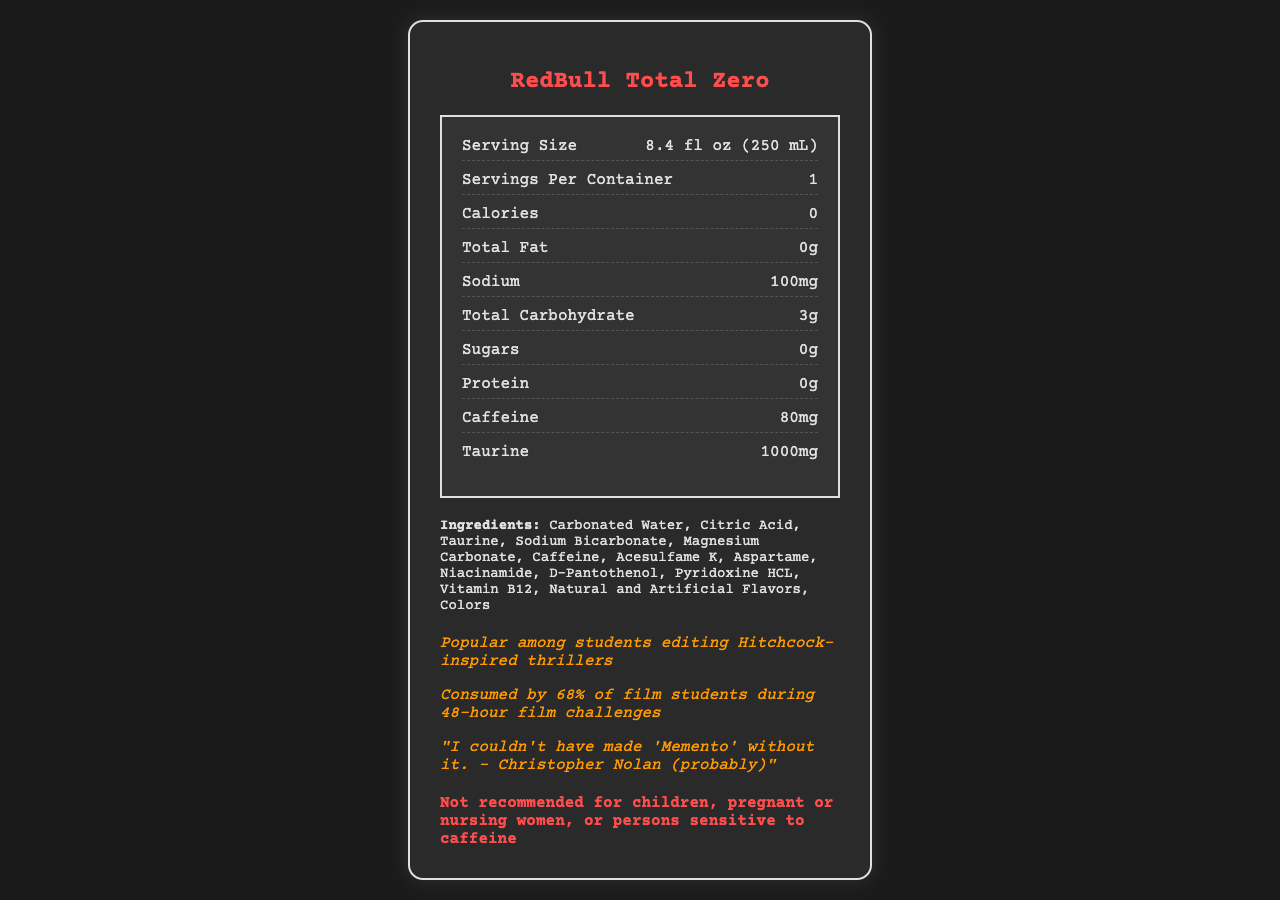what is the serving size? The serving size is listed near the top of the Nutrition Facts section of the document.
Answer: 8.4 fl oz (250 mL) how many servings are in a container? The document states "Servings Per Container" as 1.
Answer: 1 how much caffeine is in one serving? The amount of caffeine is listed under the nutrition item section.
Answer: 80mg list three key vitamins found in this energy drink. These vitamins are listed in the nutrition items section near the bottom.
Answer: vitamin b6, vitamin b12, niacin what is the total carbohydrate content per serving? The total carbohydrate content is listed under "Total Carbohydrate" in the nutrition section.
Answer: 3g which of these is NOT an ingredient in this energy drink? A. Taurine B. Magnesium Carbonate C. Glucose D. Acesulfame K The ingredients list includes Taurine, Magnesium Carbonate, and Acesulfame K, but not Glucose.
Answer: C. Glucose what is the warning regarding who should not consume this drink? A. Children B. Pregnant Women C. Persons sensitive to caffeine D. All of the above The warning section specifies that the drink is not recommended for children, pregnant or nursing women, or persons sensitive to caffeine.
Answer: D. All of the above does this energy drink contain any sugars? The document lists "Sugars" as 0g.
Answer: No is there any protein in this energy drink? The document lists "Protein" as 0g.
Answer: No summarize the main idea of the document. The document serves to provide comprehensive details about RedBull Total Zero, including its nutritional values, ingredients, and consumption advisories, emphasizing its popularity among film students.
Answer: The document presents the nutritional facts and ingredients of "RedBull Total Zero," an energy drink popular among film students. It includes information like calories, caffeine, vitamins, and a special note about its popularity and a warning about who should not consume it. describe the popularity of this energy drink among film students. The document includes trivia and statistics indicating the drink's popularity among film students.
Answer: It is popular among students editing Hitchcock-inspired thrillers and is consumed by 68% of film students during 48-hour film challenges. how much taurine is included per serving? The amount of Taurine per serving is listed in the Nutrition Facts section.
Answer: 1000mg how many calories are there in this energy drink? A. 50 B. 20 C. 0 D. 100 The document lists the calorie content as 0.
Answer: C. 0 how much sodium does this energy drink contain? The sodium content is listed under the sodium item in the nutrition section.
Answer: 100mg what film director is referenced in the document's trivia? The trivia section includes a fictional quote attributed to Christopher Nolan.
Answer: Christopher Nolan what is the pantothenic acid content in this energy drink? The document lists the amount of pantothenic acid under the nutrition section.
Answer: 5mg what color scheme and design elements are used in the document? The HTML and CSS styles indicate the color scheme and design elements utilized in creating the document, focusing on aesthetic presentation.
Answer: The document uses a dark color scheme with background colors like #1a1a1a and #2a2a2a, along with border colors like #e0e0e0 and text colors such as #ff4d4d (red) and #ff9900 (orange). The design includes a border, padding, and shadow effects for emphasis. 